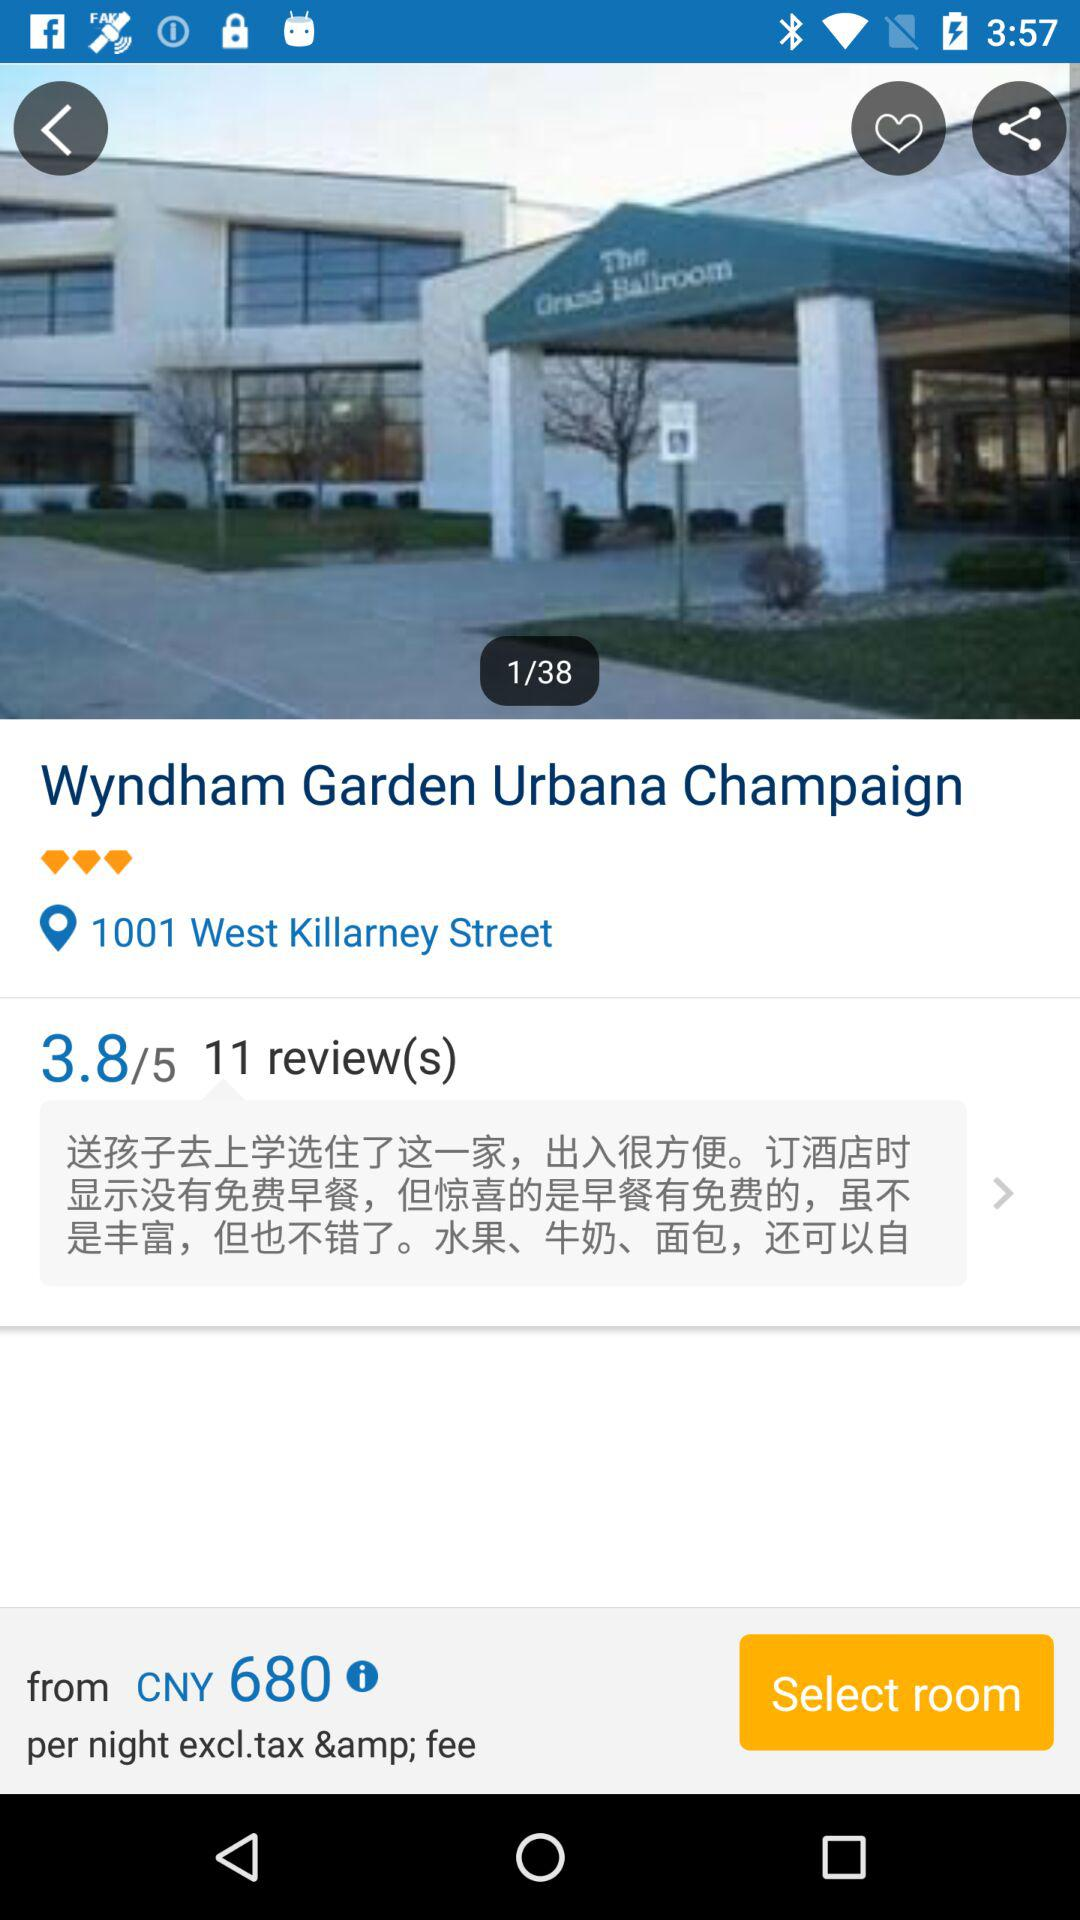How many reviews have been written about this hotel?
Answer the question using a single word or phrase. 11 